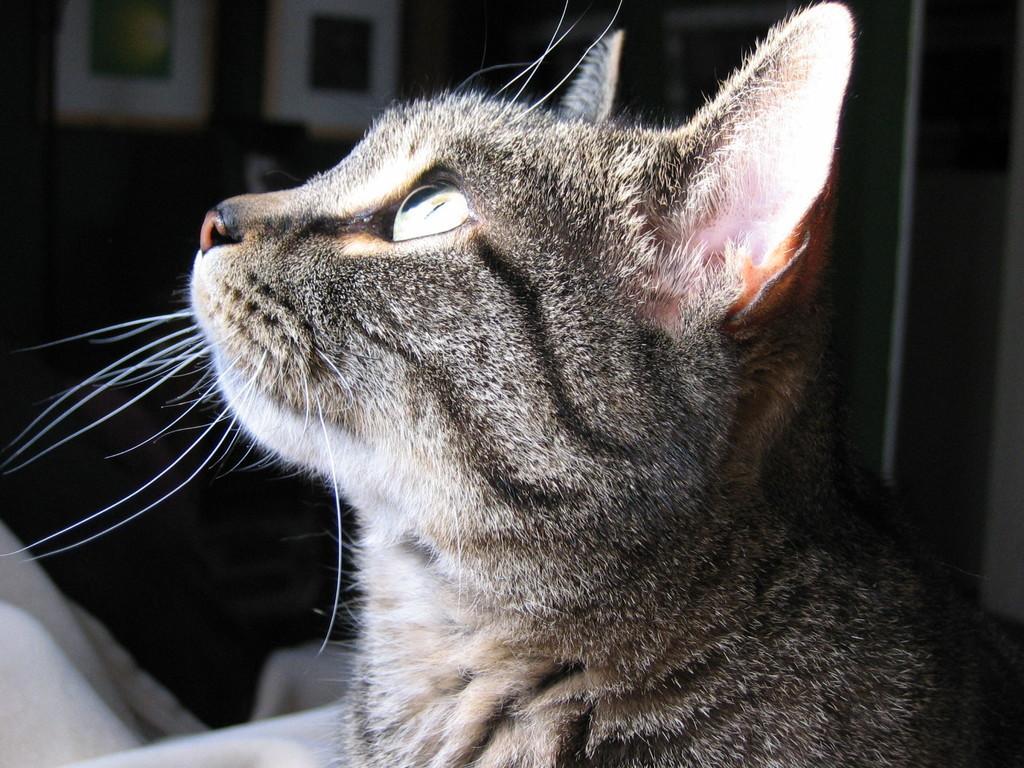Describe this image in one or two sentences. Here we can see a cat looking upwards. Background it is dark. 